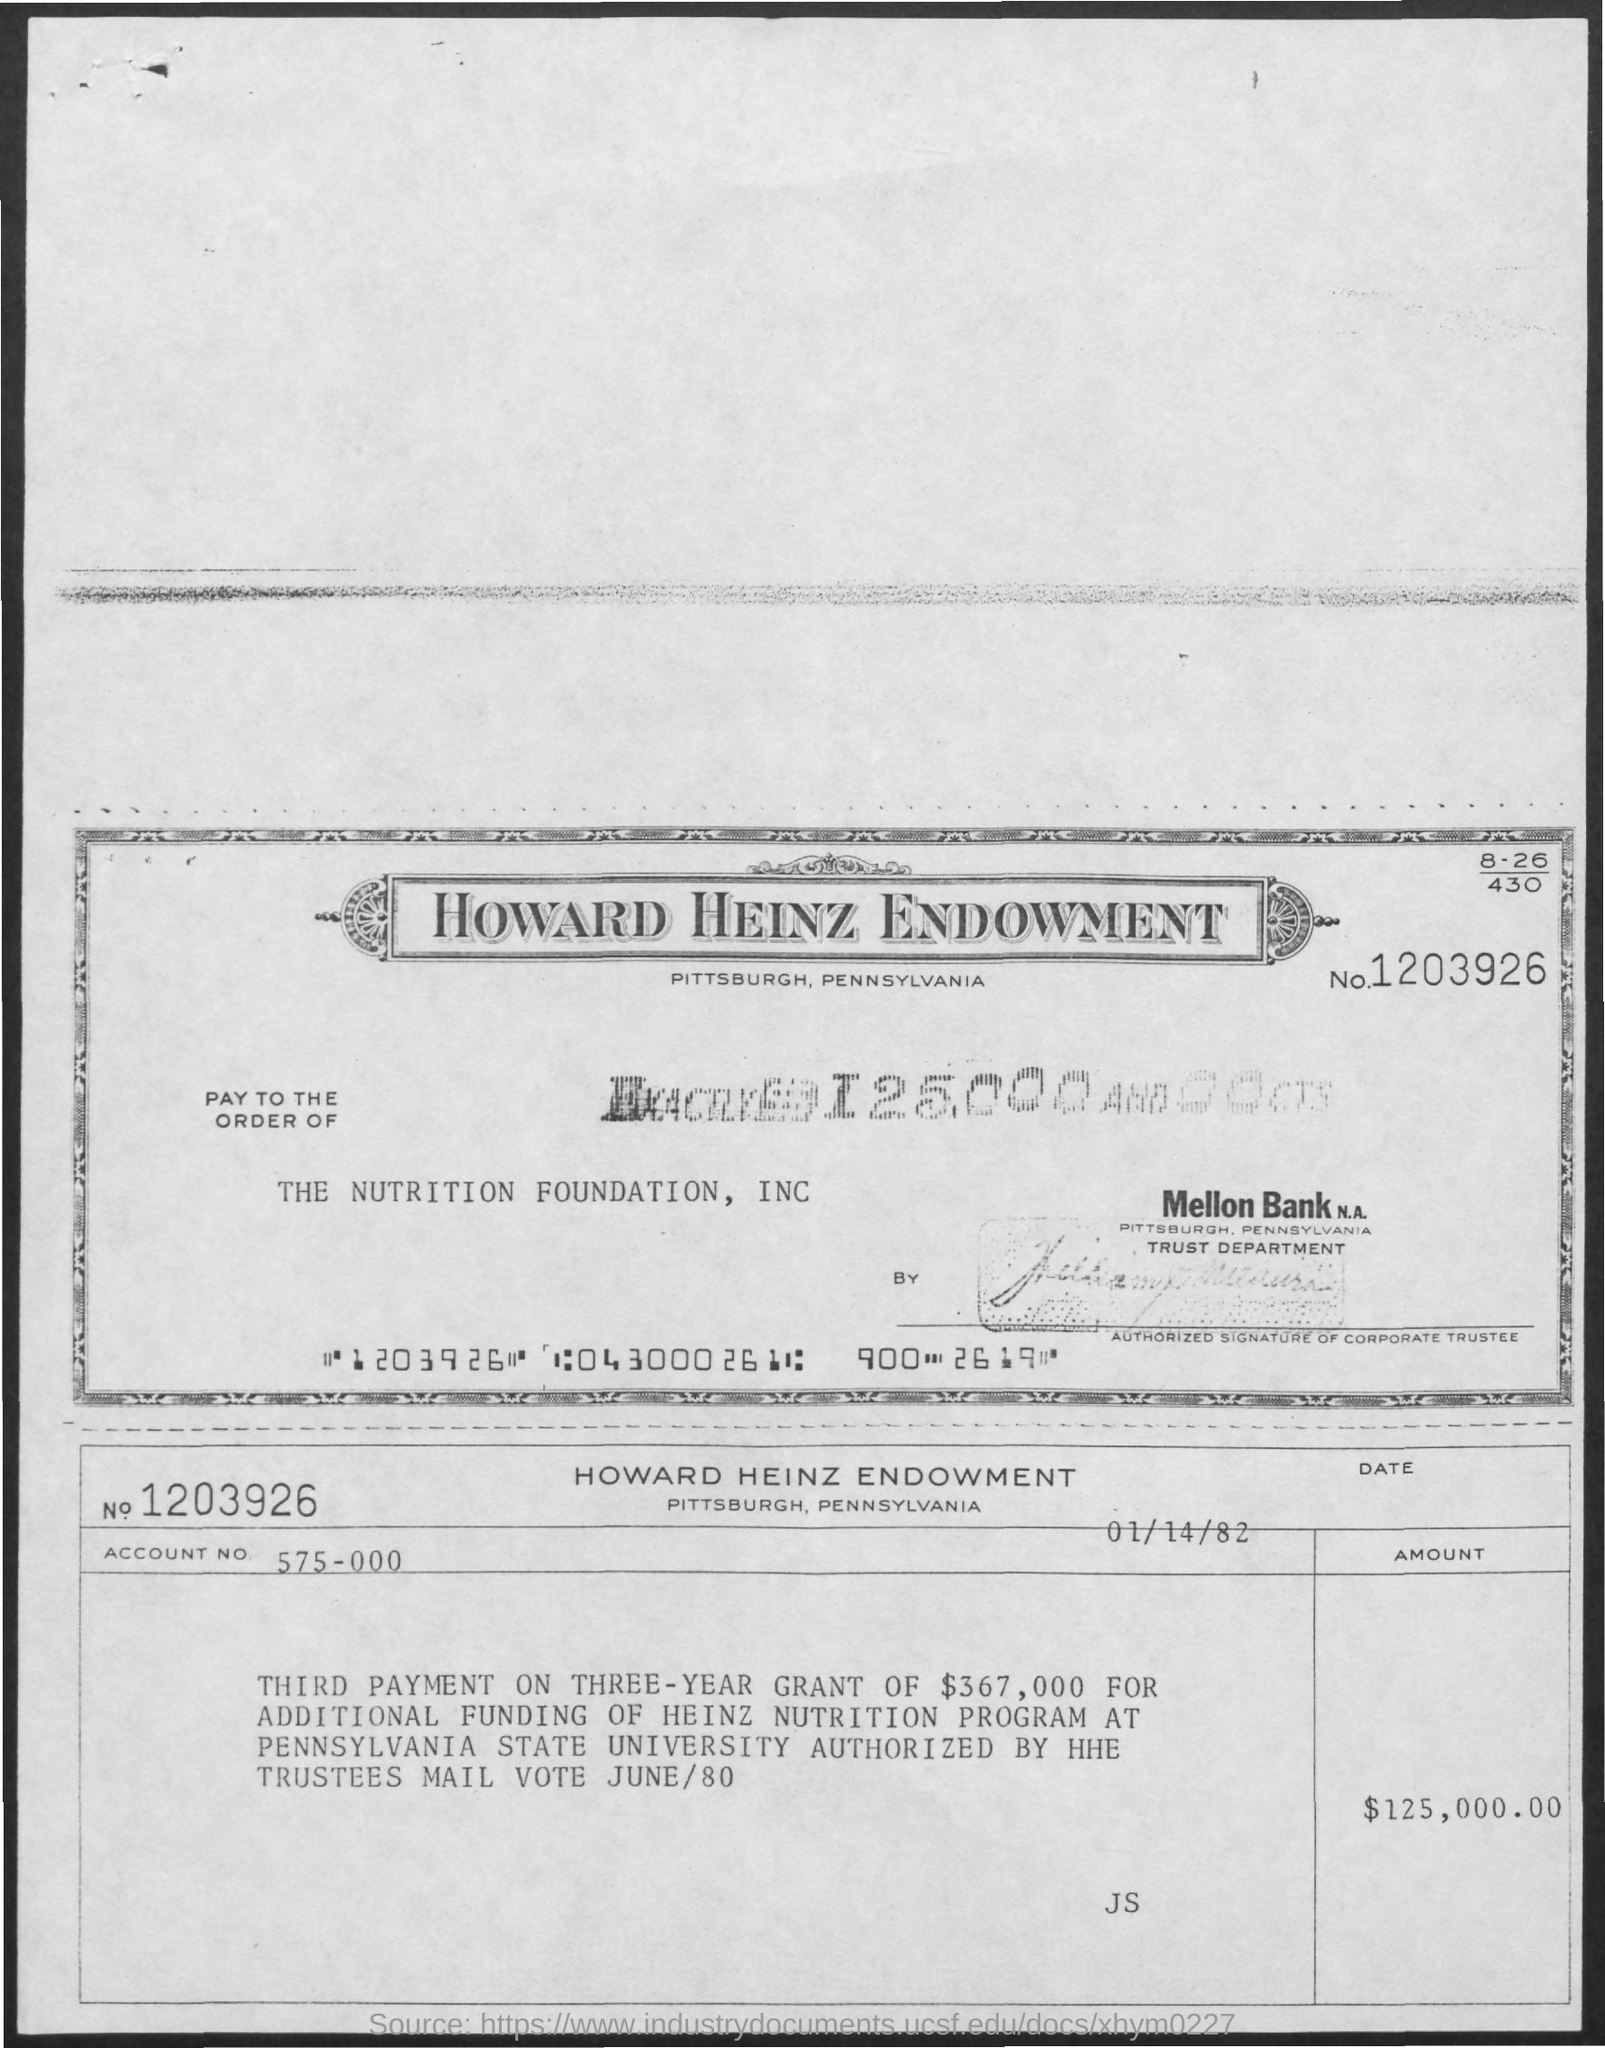Outline some significant characteristics in this image. The given page mentions a date of January 14, 1982. The account number mentioned is 575-000. The amount mentioned in the given form is $125,000 and 00 cents. The name mentioned at the order of the Nutrition Foundation, Inc. is [Insert Name]. The number mentioned in the given form is 1203926... 